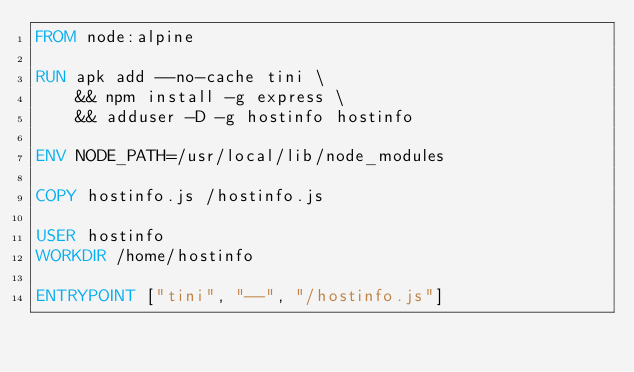Convert code to text. <code><loc_0><loc_0><loc_500><loc_500><_Dockerfile_>FROM node:alpine

RUN apk add --no-cache tini \
    && npm install -g express \
    && adduser -D -g hostinfo hostinfo

ENV NODE_PATH=/usr/local/lib/node_modules

COPY hostinfo.js /hostinfo.js

USER hostinfo
WORKDIR /home/hostinfo

ENTRYPOINT ["tini", "--", "/hostinfo.js"]
</code> 